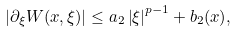Convert formula to latex. <formula><loc_0><loc_0><loc_500><loc_500>\left | \partial _ { \xi } W ( x , \xi ) \right | \leq a _ { 2 } \left | \xi \right | ^ { p - 1 } + b _ { 2 } ( x ) ,</formula> 